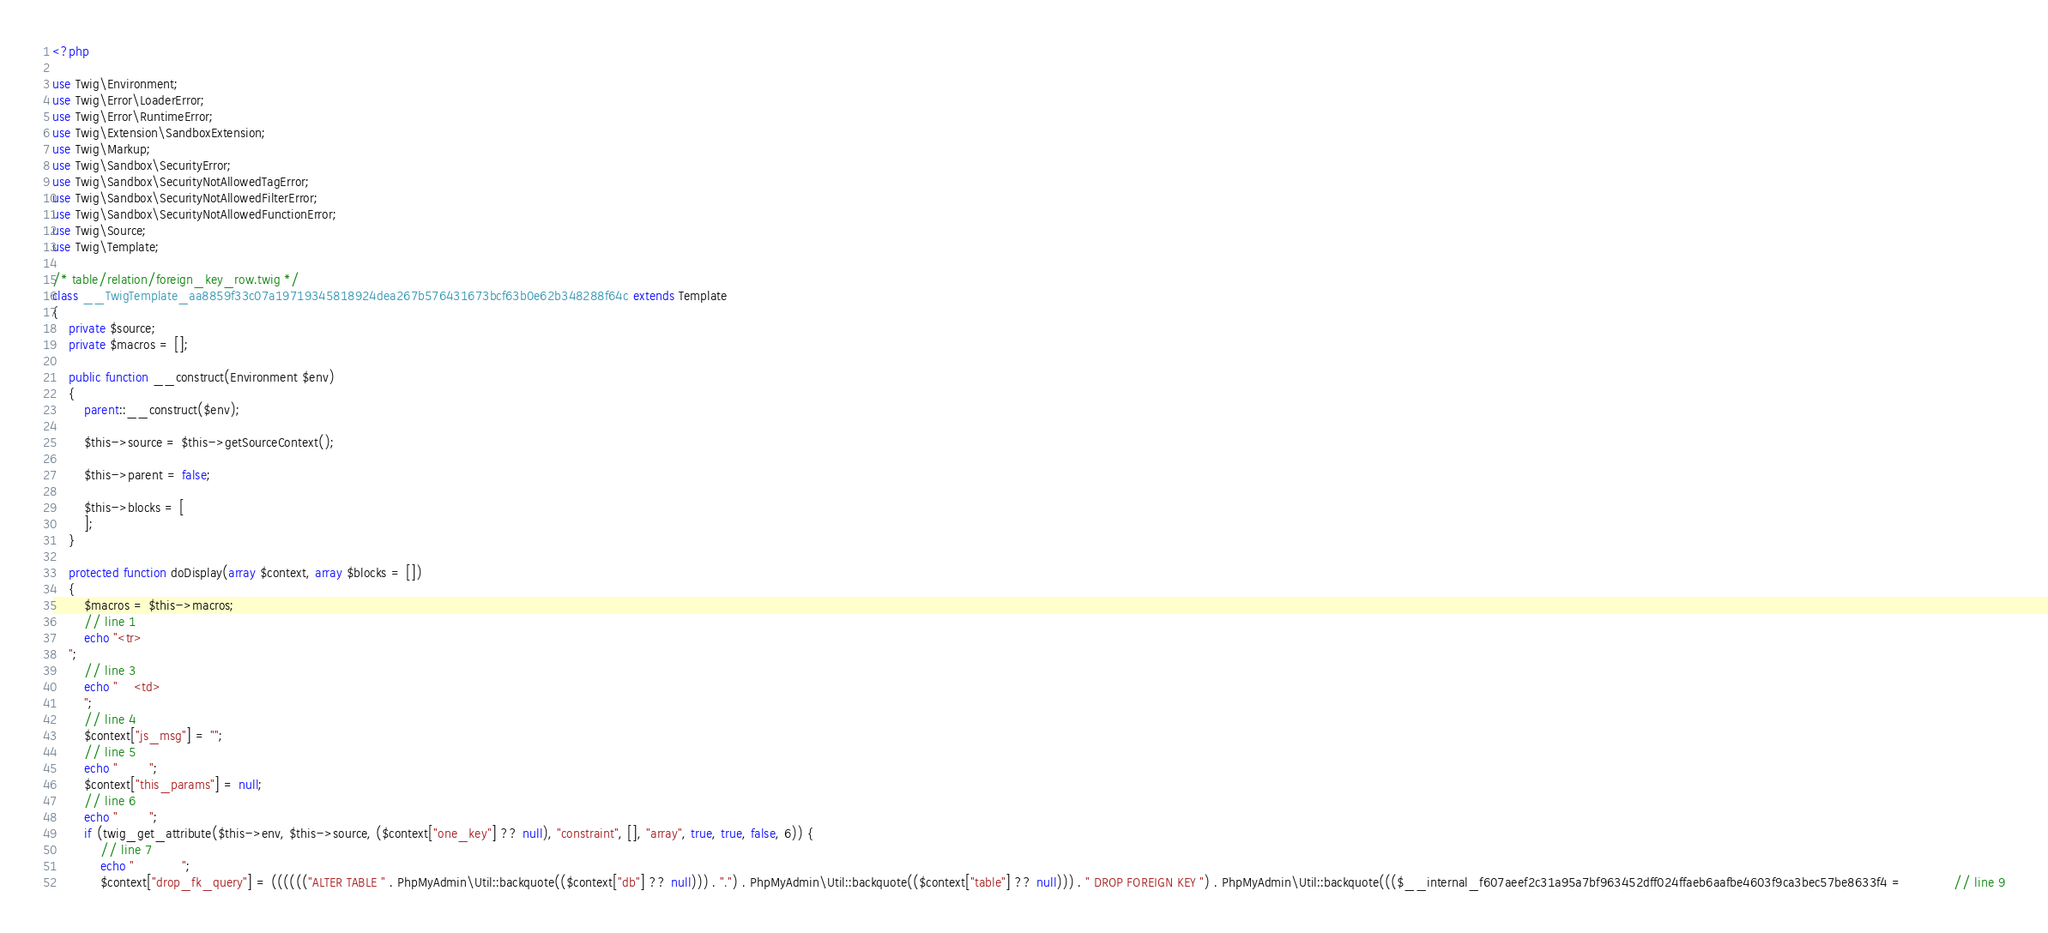<code> <loc_0><loc_0><loc_500><loc_500><_PHP_><?php

use Twig\Environment;
use Twig\Error\LoaderError;
use Twig\Error\RuntimeError;
use Twig\Extension\SandboxExtension;
use Twig\Markup;
use Twig\Sandbox\SecurityError;
use Twig\Sandbox\SecurityNotAllowedTagError;
use Twig\Sandbox\SecurityNotAllowedFilterError;
use Twig\Sandbox\SecurityNotAllowedFunctionError;
use Twig\Source;
use Twig\Template;

/* table/relation/foreign_key_row.twig */
class __TwigTemplate_aa8859f33c07a19719345818924dea267b576431673bcf63b0e62b348288f64c extends Template
{
    private $source;
    private $macros = [];

    public function __construct(Environment $env)
    {
        parent::__construct($env);

        $this->source = $this->getSourceContext();

        $this->parent = false;

        $this->blocks = [
        ];
    }

    protected function doDisplay(array $context, array $blocks = [])
    {
        $macros = $this->macros;
        // line 1
        echo "<tr>
    ";
        // line 3
        echo "    <td>
        ";
        // line 4
        $context["js_msg"] = "";
        // line 5
        echo "        ";
        $context["this_params"] = null;
        // line 6
        echo "        ";
        if (twig_get_attribute($this->env, $this->source, ($context["one_key"] ?? null), "constraint", [], "array", true, true, false, 6)) {
            // line 7
            echo "            ";
            $context["drop_fk_query"] = (((((("ALTER TABLE " . PhpMyAdmin\Util::backquote(($context["db"] ?? null))) . ".") . PhpMyAdmin\Util::backquote(($context["table"] ?? null))) . " DROP FOREIGN KEY ") . PhpMyAdmin\Util::backquote((($__internal_f607aeef2c31a95a7bf963452dff024ffaeb6aafbe4603f9ca3bec57be8633f4 =             // line 9</code> 